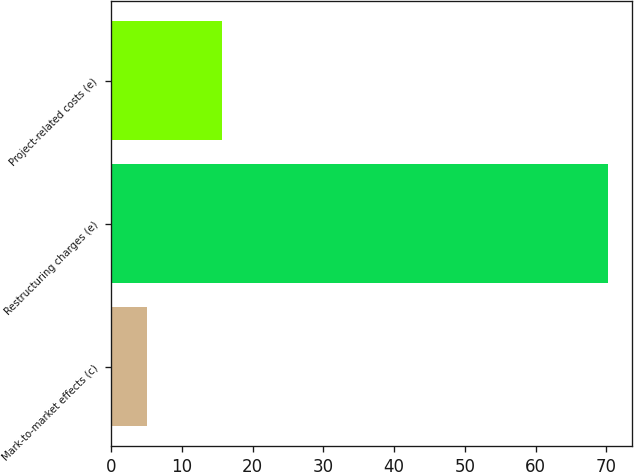Convert chart to OTSL. <chart><loc_0><loc_0><loc_500><loc_500><bar_chart><fcel>Mark-to-market effects (c)<fcel>Restructuring charges (e)<fcel>Project-related costs (e)<nl><fcel>5.1<fcel>70.2<fcel>15.7<nl></chart> 